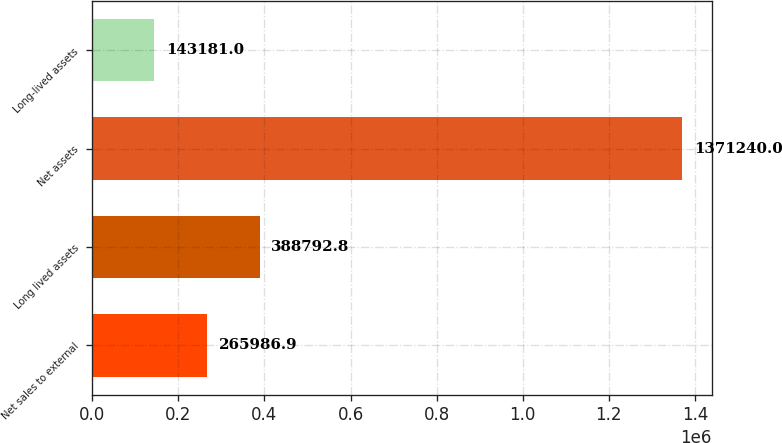Convert chart to OTSL. <chart><loc_0><loc_0><loc_500><loc_500><bar_chart><fcel>Net sales to external<fcel>Long lived assets<fcel>Net assets<fcel>Long-lived assets<nl><fcel>265987<fcel>388793<fcel>1.37124e+06<fcel>143181<nl></chart> 